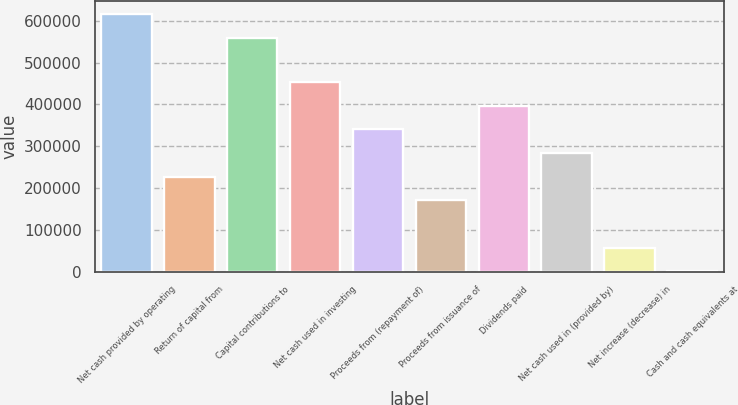<chart> <loc_0><loc_0><loc_500><loc_500><bar_chart><fcel>Net cash provided by operating<fcel>Return of capital from<fcel>Capital contributions to<fcel>Net cash used in investing<fcel>Proceeds from (repayment of)<fcel>Proceeds from issuance of<fcel>Dividends paid<fcel>Net cash used in (provided by)<fcel>Net increase (decrease) in<fcel>Cash and cash equivalents at<nl><fcel>615882<fcel>226989<fcel>559266<fcel>453455<fcel>340222<fcel>170372<fcel>396838<fcel>283606<fcel>57139.5<fcel>523<nl></chart> 